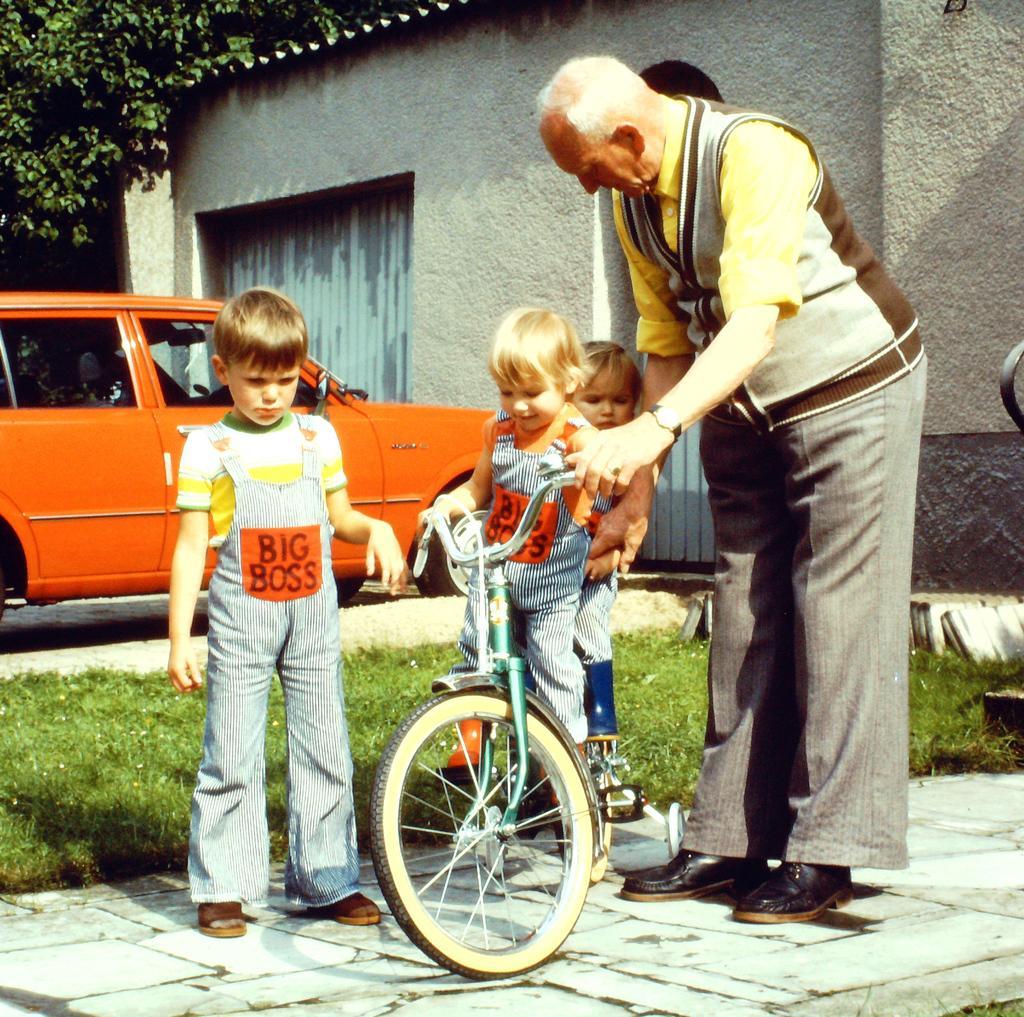Please provide a concise description of this image. In this image we can see two children are on the bicycle. We can see a child and an old man standing beside them. In the background we can see a car, building and trees. 